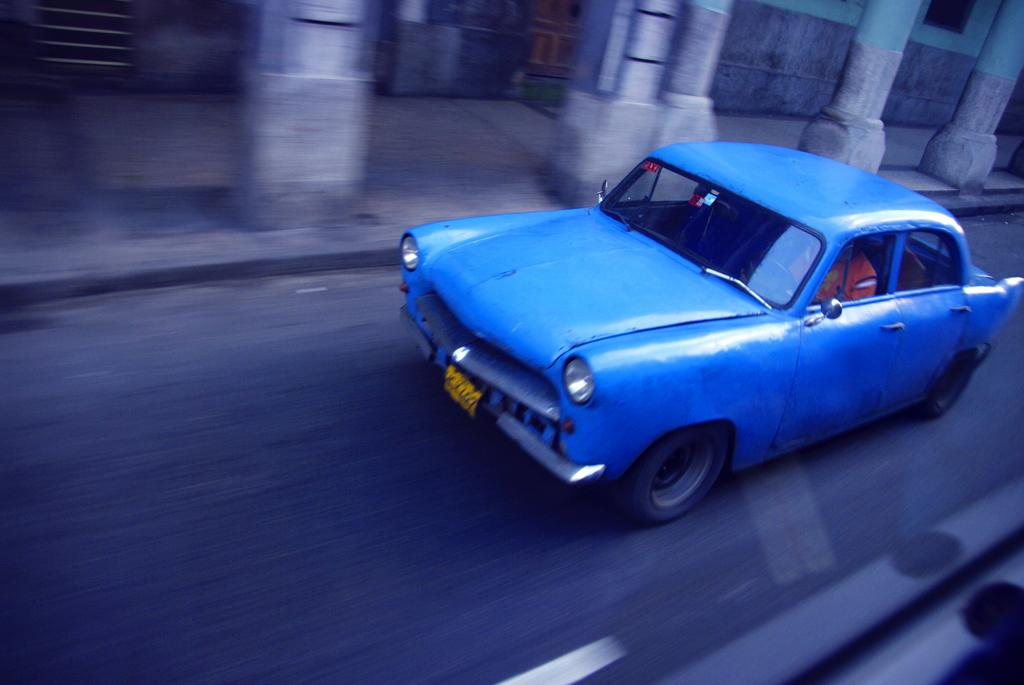What type of vehicle is in the image? There is a blue car in the image. Who is inside the car? A man is visible inside the car. What is at the bottom of the image? There is a road at the bottom of the image. What can be seen in the background of the image? There are pillars and a building in the background of the image. How many cows are grazing on the side of the road in the image? There are no cows visible in the image; it only features a blue car, a man inside the car, a road, pillars, and a building in the background. 